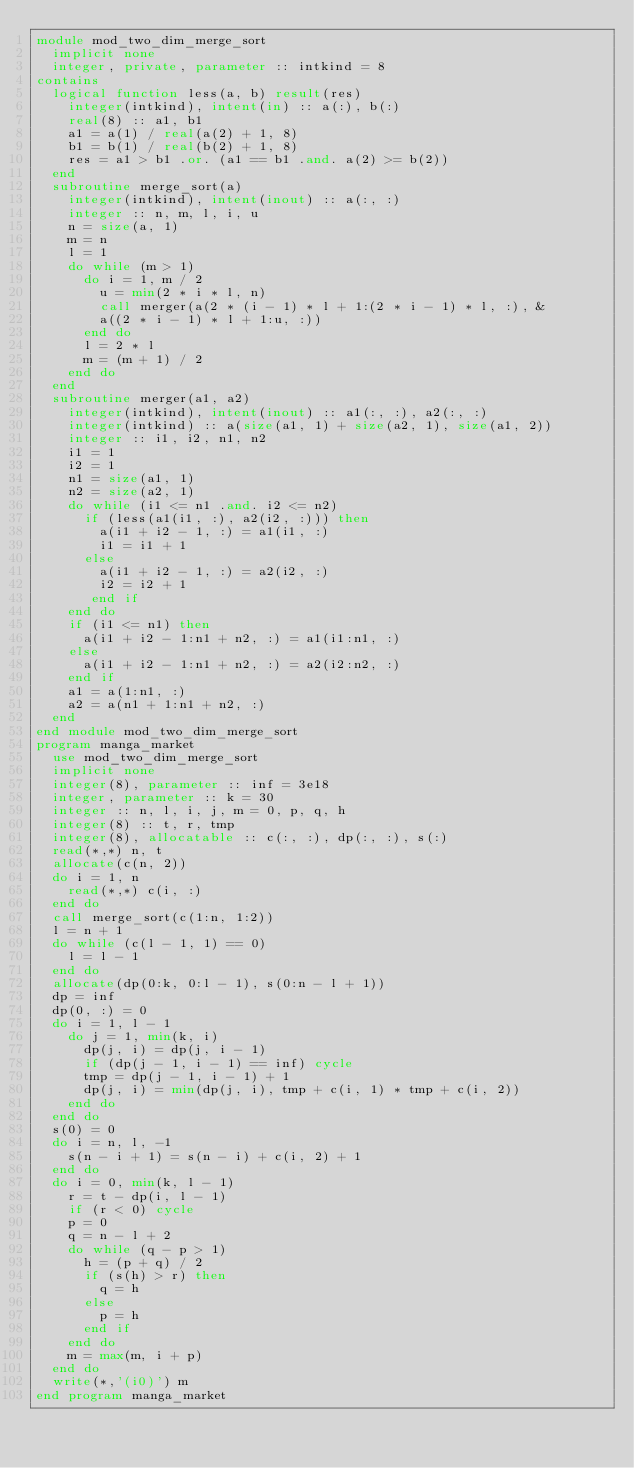<code> <loc_0><loc_0><loc_500><loc_500><_FORTRAN_>module mod_two_dim_merge_sort
  implicit none
  integer, private, parameter :: intkind = 8
contains
  logical function less(a, b) result(res)
    integer(intkind), intent(in) :: a(:), b(:)
    real(8) :: a1, b1
    a1 = a(1) / real(a(2) + 1, 8)
    b1 = b(1) / real(b(2) + 1, 8)
    res = a1 > b1 .or. (a1 == b1 .and. a(2) >= b(2))
  end
  subroutine merge_sort(a)
    integer(intkind), intent(inout) :: a(:, :)
    integer :: n, m, l, i, u
    n = size(a, 1)
    m = n
    l = 1
    do while (m > 1)
      do i = 1, m / 2
        u = min(2 * i * l, n)
        call merger(a(2 * (i - 1) * l + 1:(2 * i - 1) * l, :), &
        a((2 * i - 1) * l + 1:u, :))
      end do
      l = 2 * l
      m = (m + 1) / 2
    end do
  end
  subroutine merger(a1, a2)
    integer(intkind), intent(inout) :: a1(:, :), a2(:, :)
    integer(intkind) :: a(size(a1, 1) + size(a2, 1), size(a1, 2))
    integer :: i1, i2, n1, n2
    i1 = 1
    i2 = 1
    n1 = size(a1, 1)
    n2 = size(a2, 1)
    do while (i1 <= n1 .and. i2 <= n2)
      if (less(a1(i1, :), a2(i2, :))) then
        a(i1 + i2 - 1, :) = a1(i1, :)
        i1 = i1 + 1
      else
        a(i1 + i2 - 1, :) = a2(i2, :)
        i2 = i2 + 1
       end if
    end do
    if (i1 <= n1) then
      a(i1 + i2 - 1:n1 + n2, :) = a1(i1:n1, :)
    else
      a(i1 + i2 - 1:n1 + n2, :) = a2(i2:n2, :)
    end if
    a1 = a(1:n1, :)
    a2 = a(n1 + 1:n1 + n2, :)
  end
end module mod_two_dim_merge_sort
program manga_market
  use mod_two_dim_merge_sort
  implicit none
  integer(8), parameter :: inf = 3e18
  integer, parameter :: k = 30
  integer :: n, l, i, j, m = 0, p, q, h
  integer(8) :: t, r, tmp
  integer(8), allocatable :: c(:, :), dp(:, :), s(:)
  read(*,*) n, t
  allocate(c(n, 2))
  do i = 1, n
    read(*,*) c(i, :)
  end do
  call merge_sort(c(1:n, 1:2))
  l = n + 1
  do while (c(l - 1, 1) == 0)
    l = l - 1
  end do
  allocate(dp(0:k, 0:l - 1), s(0:n - l + 1))
  dp = inf
  dp(0, :) = 0
  do i = 1, l - 1
    do j = 1, min(k, i)
      dp(j, i) = dp(j, i - 1)
      if (dp(j - 1, i - 1) == inf) cycle
      tmp = dp(j - 1, i - 1) + 1
      dp(j, i) = min(dp(j, i), tmp + c(i, 1) * tmp + c(i, 2))
    end do
  end do
  s(0) = 0
  do i = n, l, -1
    s(n - i + 1) = s(n - i) + c(i, 2) + 1
  end do
  do i = 0, min(k, l - 1)
    r = t - dp(i, l - 1)
    if (r < 0) cycle
    p = 0
    q = n - l + 2
    do while (q - p > 1)
      h = (p + q) / 2
      if (s(h) > r) then
        q = h
      else
        p = h
      end if
    end do
    m = max(m, i + p)
  end do
  write(*,'(i0)') m
end program manga_market</code> 